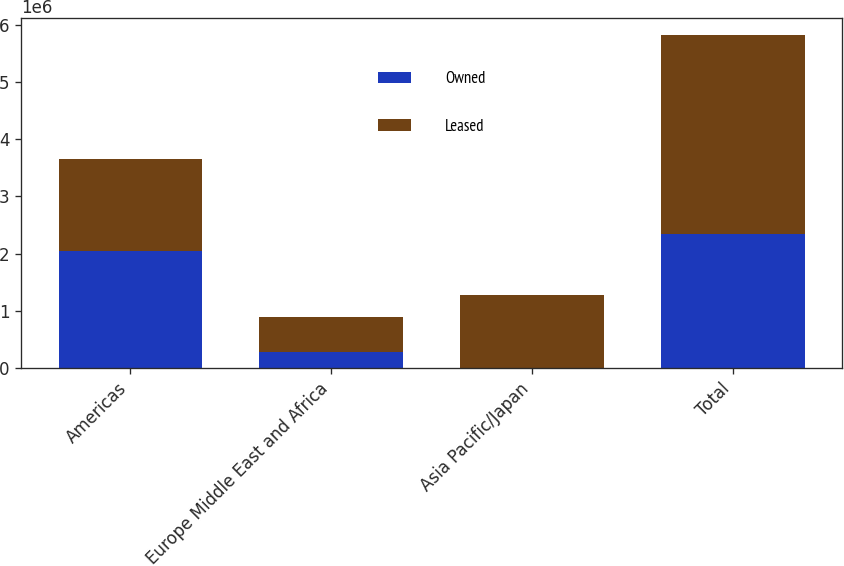<chart> <loc_0><loc_0><loc_500><loc_500><stacked_bar_chart><ecel><fcel>Americas<fcel>Europe Middle East and Africa<fcel>Asia Pacific/Japan<fcel>Total<nl><fcel>Owned<fcel>2.044e+06<fcel>285000<fcel>5000<fcel>2.334e+06<nl><fcel>Leased<fcel>1.616e+06<fcel>598000<fcel>1.277e+06<fcel>3.491e+06<nl></chart> 